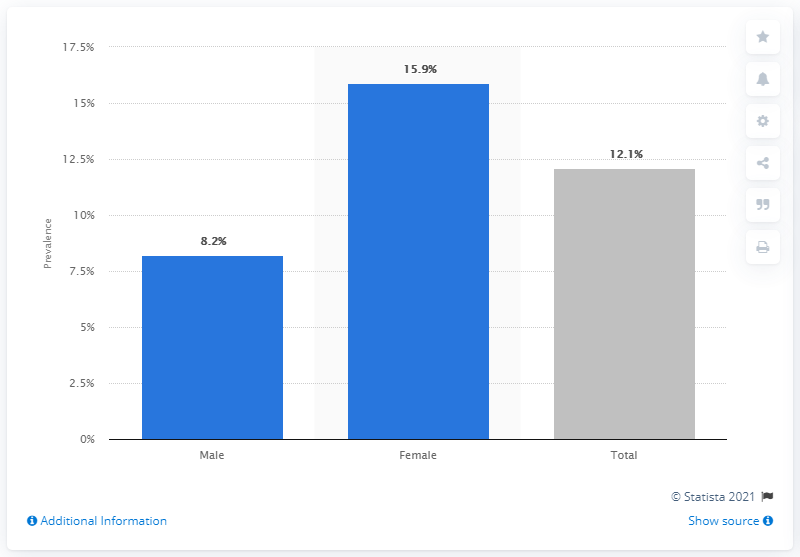Point out several critical features in this image. It is estimated that in 2015-2016, 15.9% of females had genital herpes. 